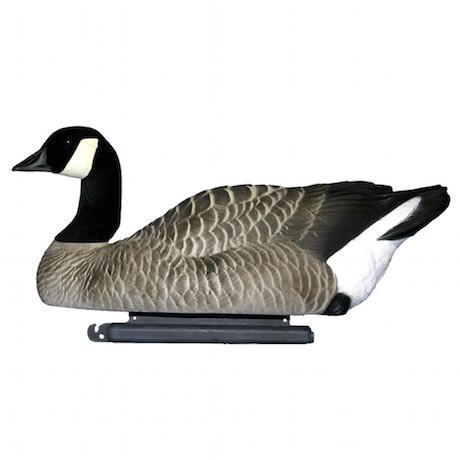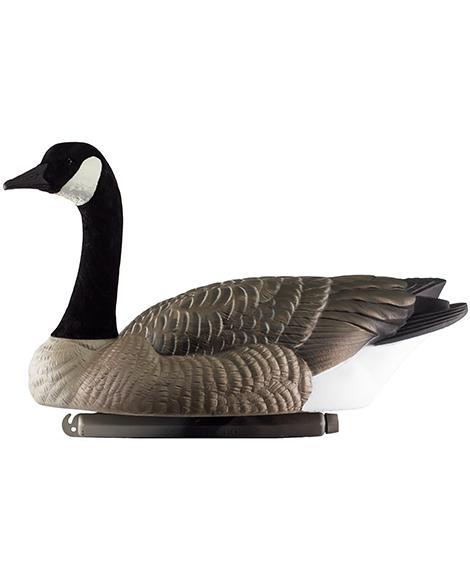The first image is the image on the left, the second image is the image on the right. Assess this claim about the two images: "All decoy birds have black necks, and one image contains at least four decoy birds, while the other image contains just one.". Correct or not? Answer yes or no. No. The first image is the image on the left, the second image is the image on the right. For the images displayed, is the sentence "There are five duck decoys." factually correct? Answer yes or no. No. 